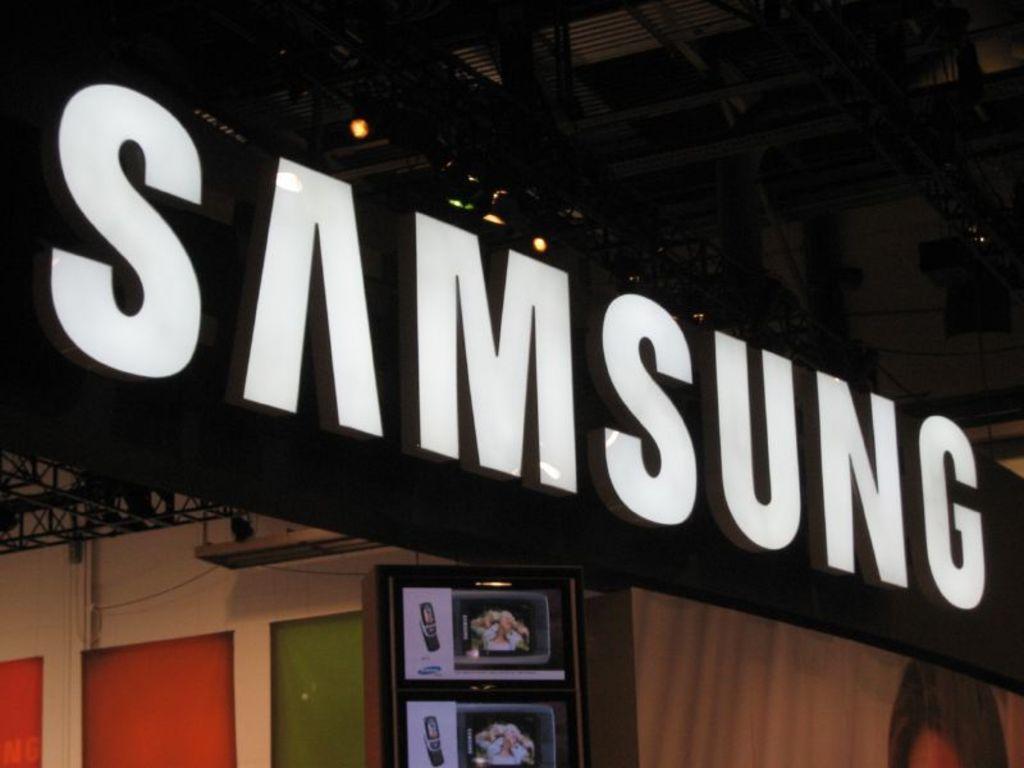Describe this image in one or two sentences. In this image there is a board with some text is hanging from the ceiling and there is a board with some images is hanging on the wall, beside that there are a few color blocks attached to the wall, on the other side there is like a curtain. 